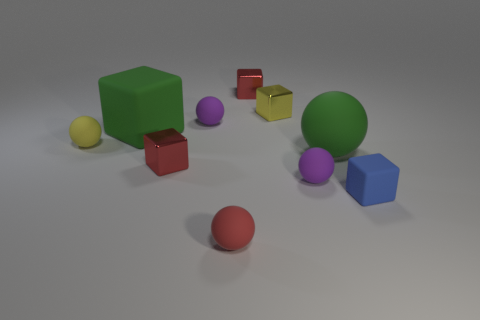Subtract all big green cubes. How many cubes are left? 4 Subtract all purple spheres. How many spheres are left? 3 Subtract all purple cylinders. How many yellow blocks are left? 1 Add 6 cyan matte things. How many cyan matte things exist? 6 Subtract 0 gray cylinders. How many objects are left? 10 Subtract 4 blocks. How many blocks are left? 1 Subtract all cyan cubes. Subtract all yellow balls. How many cubes are left? 5 Subtract all tiny red shiny blocks. Subtract all small yellow metallic things. How many objects are left? 7 Add 6 green rubber blocks. How many green rubber blocks are left? 7 